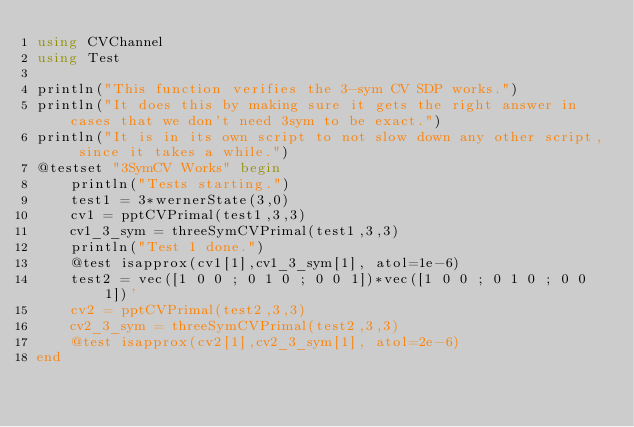<code> <loc_0><loc_0><loc_500><loc_500><_Julia_>using CVChannel
using Test

println("This function verifies the 3-sym CV SDP works.")
println("It does this by making sure it gets the right answer in cases that we don't need 3sym to be exact.")
println("It is in its own script to not slow down any other script, since it takes a while.")
@testset "3SymCV Works" begin
    println("Tests starting.")
    test1 = 3*wernerState(3,0)
    cv1 = pptCVPrimal(test1,3,3)
    cv1_3_sym = threeSymCVPrimal(test1,3,3)
    println("Test 1 done.")
    @test isapprox(cv1[1],cv1_3_sym[1], atol=1e-6)
    test2 = vec([1 0 0 ; 0 1 0 ; 0 0 1])*vec([1 0 0 ; 0 1 0 ; 0 0 1])'
    cv2 = pptCVPrimal(test2,3,3)
    cv2_3_sym = threeSymCVPrimal(test2,3,3)
    @test isapprox(cv2[1],cv2_3_sym[1], atol=2e-6)
end
</code> 